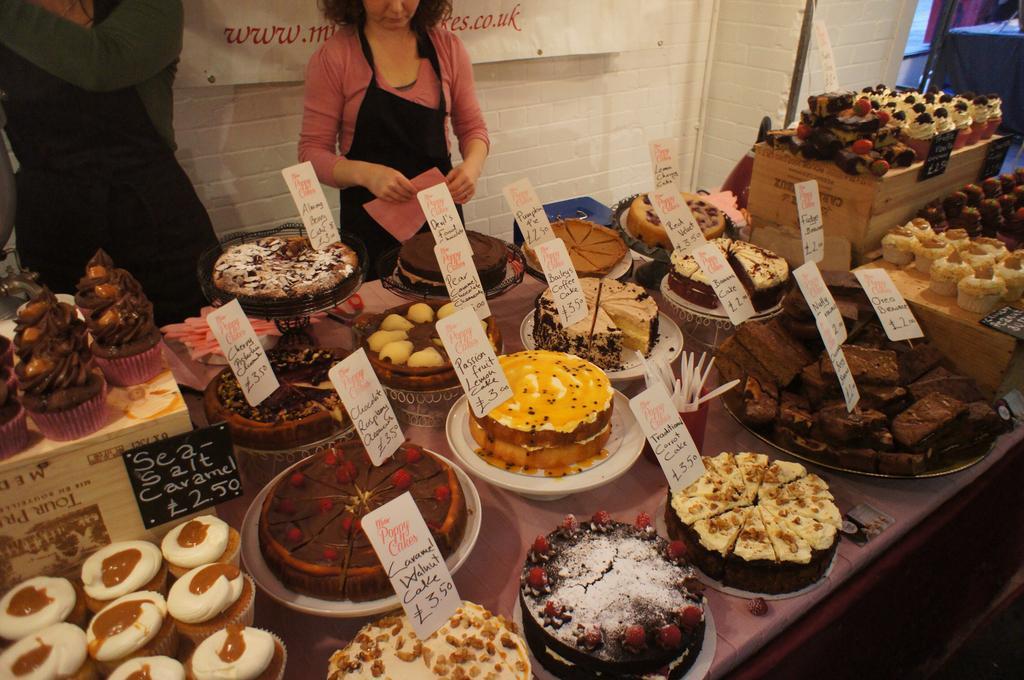Could you give a brief overview of what you see in this image? In this image we can see different kinds of foods placed on the serving plates along with their name boards. In the background there are persons standing on the floor. 